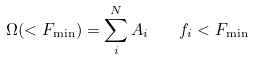Convert formula to latex. <formula><loc_0><loc_0><loc_500><loc_500>\Omega ( < F _ { \min } ) = \sum _ { i } ^ { N } A _ { i } \quad f _ { i } < F _ { \min }</formula> 